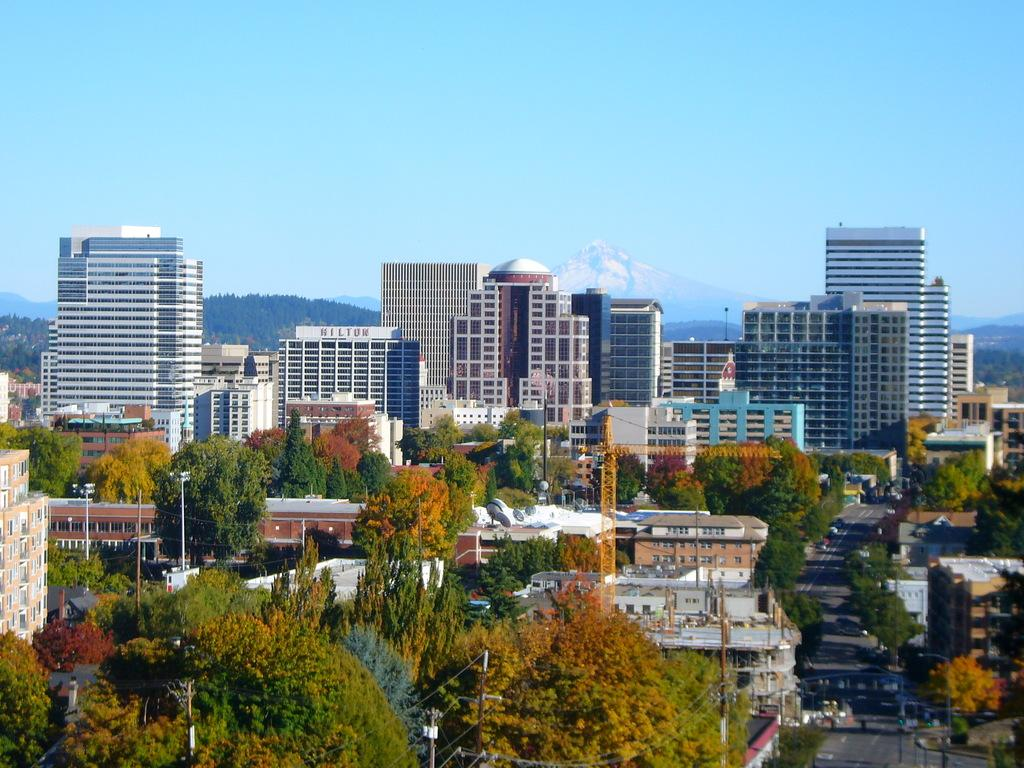What type of structures can be seen in the image? There are buildings in the image. What other natural elements are present in the image? There are trees in the image. What mode of transportation can be seen on the road in the image? There are vehicles on the road in the image. What vertical structures are visible in the image? Utility poles are visible in the image. What geographical feature can be seen in the background of the image? There are mountains in the image. What part of the environment is visible above the buildings and trees? The sky is visible in the image. What letters are visible on the engine of the vehicle in the image? There is no engine visible in the image, as the vehicles are not described in detail. What type of transport is being used by the letters in the image? There are no letters present in the image, so it is not possible to determine what type of transport they might be using. 